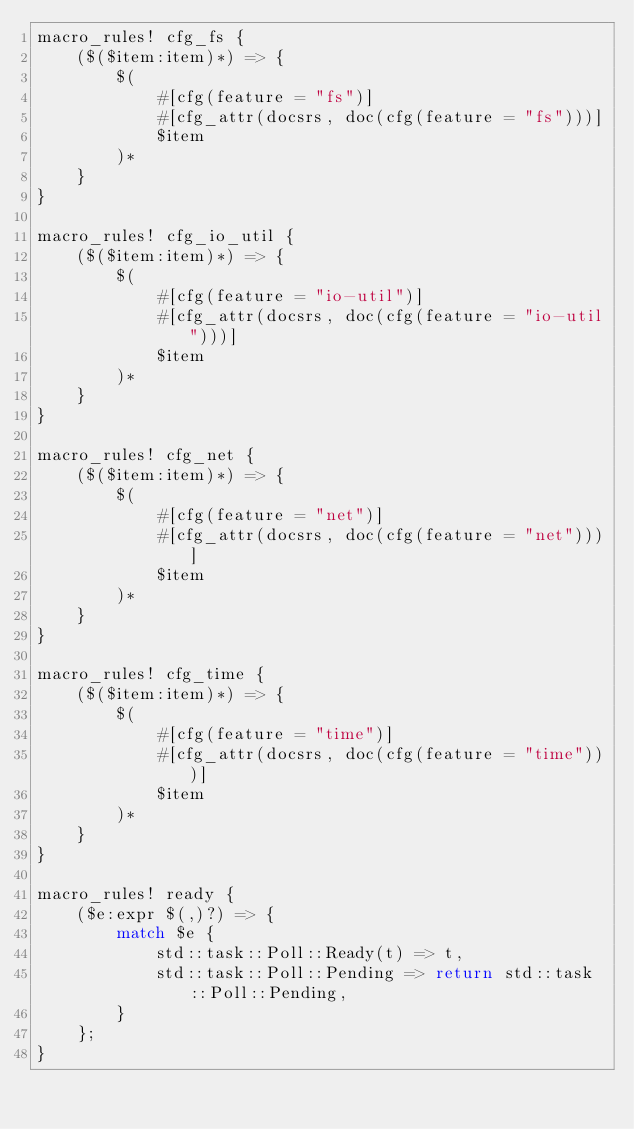Convert code to text. <code><loc_0><loc_0><loc_500><loc_500><_Rust_>macro_rules! cfg_fs {
    ($($item:item)*) => {
        $(
            #[cfg(feature = "fs")]
            #[cfg_attr(docsrs, doc(cfg(feature = "fs")))]
            $item
        )*
    }
}

macro_rules! cfg_io_util {
    ($($item:item)*) => {
        $(
            #[cfg(feature = "io-util")]
            #[cfg_attr(docsrs, doc(cfg(feature = "io-util")))]
            $item
        )*
    }
}

macro_rules! cfg_net {
    ($($item:item)*) => {
        $(
            #[cfg(feature = "net")]
            #[cfg_attr(docsrs, doc(cfg(feature = "net")))]
            $item
        )*
    }
}

macro_rules! cfg_time {
    ($($item:item)*) => {
        $(
            #[cfg(feature = "time")]
            #[cfg_attr(docsrs, doc(cfg(feature = "time")))]
            $item
        )*
    }
}

macro_rules! ready {
    ($e:expr $(,)?) => {
        match $e {
            std::task::Poll::Ready(t) => t,
            std::task::Poll::Pending => return std::task::Poll::Pending,
        }
    };
}
</code> 